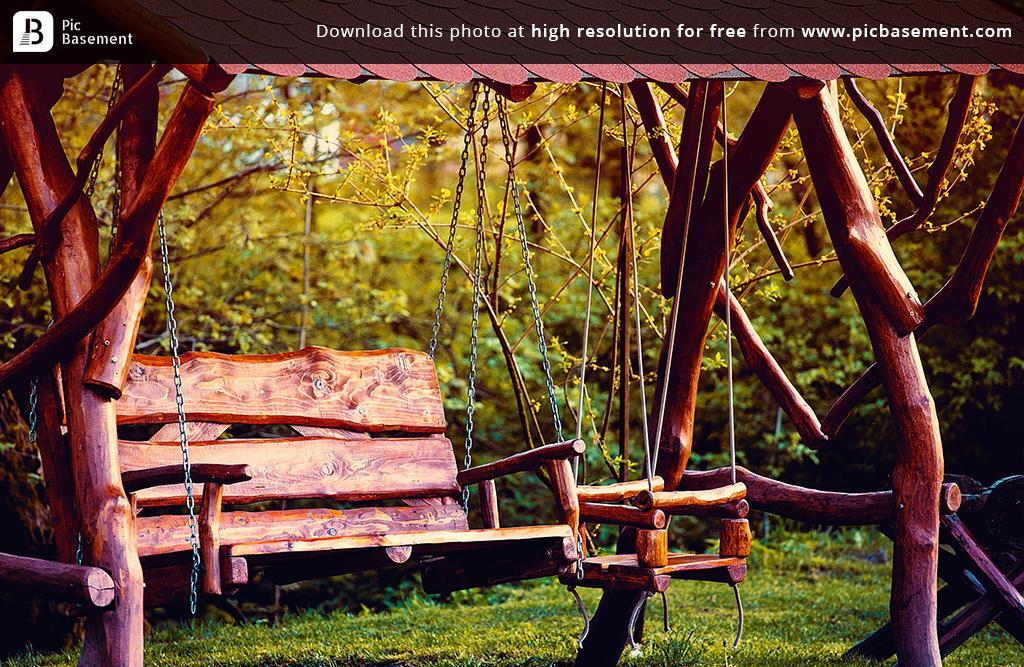Could you give a brief overview of what you see in this image? In this image I can see wooden benches attached to an object with chains. In the background I can see trees and the grass. 